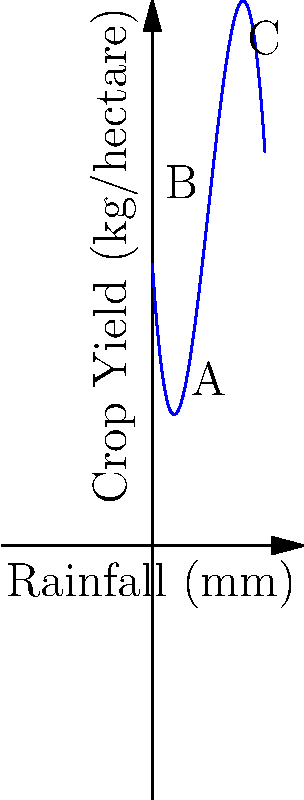The graph shows the relationship between rainfall and crop yield for an indigenous farming practice in Australia. The curve is modeled by the polynomial function $f(x) = -0.5x^3 + 6x^2 - 15x + 20$, where $x$ represents rainfall in millimeters and $f(x)$ represents crop yield in kg/hectare. What is the optimal amount of rainfall (in mm) to maximize crop yield, and what is the maximum yield (in kg/hectare) at this point? To find the optimal amount of rainfall and maximum yield, we need to follow these steps:

1. Find the derivative of the function:
   $f'(x) = -1.5x^2 + 12x - 15$

2. Set the derivative equal to zero to find critical points:
   $-1.5x^2 + 12x - 15 = 0$

3. Solve the quadratic equation:
   $-1.5(x^2 - 8x + 10) = 0$
   $-1.5(x - 2)(x - 6) = 0$
   $x = 2$ or $x = 6$

4. Calculate the second derivative:
   $f''(x) = -3x + 12$

5. Evaluate the second derivative at the critical points:
   $f''(2) = -3(2) + 12 = 6 > 0$ (local minimum)
   $f''(6) = -3(6) + 12 = -6 < 0$ (local maximum)

6. Calculate the maximum yield at $x = 6$:
   $f(6) = -0.5(6)^3 + 6(6)^2 - 15(6) + 20$
   $= -108 + 216 - 90 + 20$
   $= 38$ kg/hectare

Therefore, the optimal amount of rainfall is 6 mm, and the maximum yield at this point is 38 kg/hectare.
Answer: 6 mm rainfall; 38 kg/hectare yield 